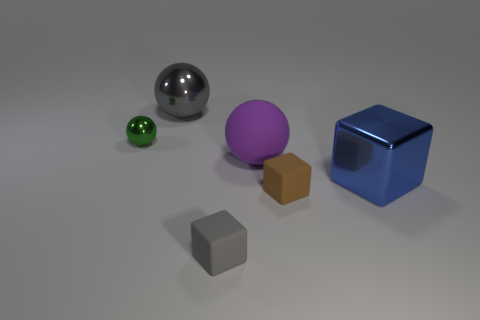There is a large thing that is both on the left side of the large shiny block and on the right side of the gray cube; what color is it?
Your response must be concise. Purple. Does the green sphere have the same material as the small gray block?
Your answer should be very brief. No. The purple rubber sphere is what size?
Provide a succinct answer. Large. The gray object that is in front of the large metallic cube has what shape?
Provide a succinct answer. Cube. Does the large matte thing have the same shape as the tiny green metallic object?
Provide a succinct answer. Yes. Are there the same number of brown blocks in front of the small metallic ball and gray matte objects?
Your response must be concise. Yes. What is the shape of the gray metal object?
Keep it short and to the point. Sphere. Is there anything else that has the same color as the large metal sphere?
Make the answer very short. Yes. Do the shiny object that is behind the small green sphere and the matte thing behind the blue metallic thing have the same size?
Give a very brief answer. Yes. There is a large thing that is on the right side of the large ball in front of the green shiny thing; what shape is it?
Offer a terse response. Cube. 